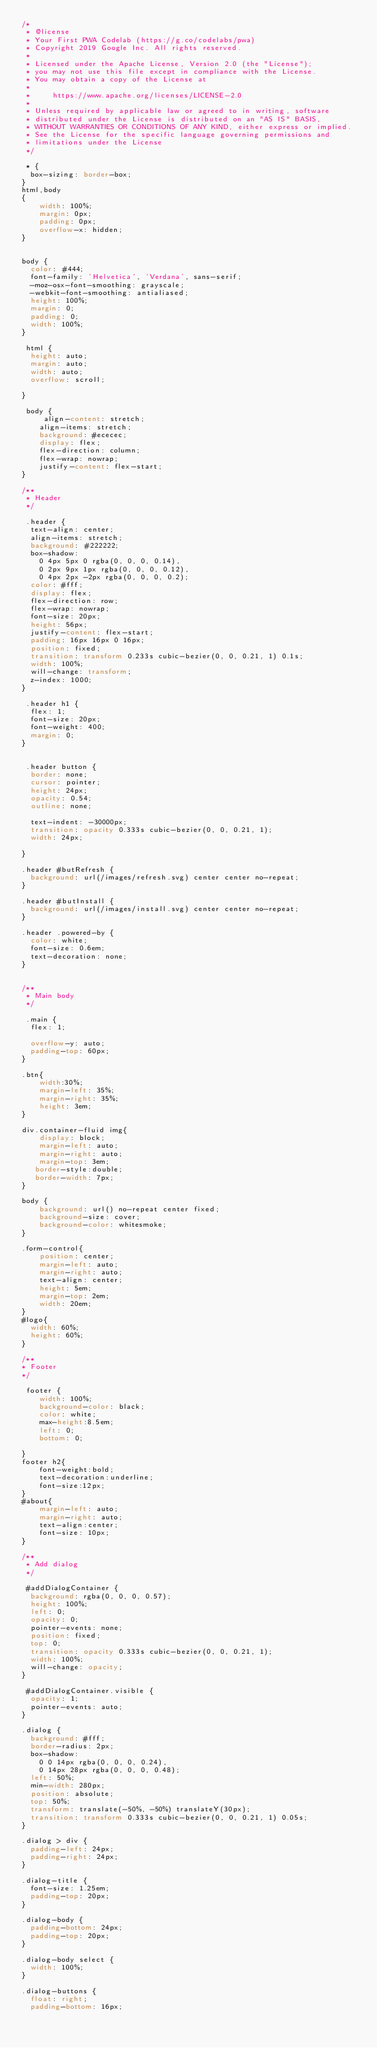<code> <loc_0><loc_0><loc_500><loc_500><_CSS_>/*
 * @license
 * Your First PWA Codelab (https://g.co/codelabs/pwa)
 * Copyright 2019 Google Inc. All rights reserved.
 *
 * Licensed under the Apache License, Version 2.0 (the "License");
 * you may not use this file except in compliance with the License.
 * You may obtain a copy of the License at
 *
 *     https://www.apache.org/licenses/LICENSE-2.0
 *
 * Unless required by applicable law or agreed to in writing, software
 * distributed under the License is distributed on an "AS IS" BASIS,
 * WITHOUT WARRANTIES OR CONDITIONS OF ANY KIND, either express or implied.
 * See the License for the specific language governing permissions and
 * limitations under the License
 */

 * {
  box-sizing: border-box;
}
html,body
{
    width: 100%;
    margin: 0px;
    padding: 0px;
    overflow-x: hidden;
}


body {
  color: #444;
  font-family: 'Helvetica', 'Verdana', sans-serif;
  -moz-osx-font-smoothing: grayscale;
  -webkit-font-smoothing: antialiased;
  height: 100%;
  margin: 0;
  padding: 0;
  width: 100%;
}

 html {
  height: auto;
  margin: auto;
  width: auto;
  overflow: scroll;

}

 body {
     align-content: stretch;
    align-items: stretch;
    background: #ececec;
    display: flex;
    flex-direction: column;
    flex-wrap: nowrap;
    justify-content: flex-start;
}

/**
 * Header
 */

 .header {
  text-align: center;
  align-items: stretch;
  background: #222222;
  box-shadow:
    0 4px 5px 0 rgba(0, 0, 0, 0.14),
    0 2px 9px 1px rgba(0, 0, 0, 0.12),
    0 4px 2px -2px rgba(0, 0, 0, 0.2);
  color: #fff;
  display: flex;
  flex-direction: row;
  flex-wrap: nowrap;
  font-size: 20px;
  height: 56px;
  justify-content: flex-start;
  padding: 16px 16px 0 16px;
  position: fixed;
  transition: transform 0.233s cubic-bezier(0, 0, 0.21, 1) 0.1s;
  width: 100%;
  will-change: transform;
  z-index: 1000;
}

 .header h1 {
  flex: 1;
  font-size: 20px;
  font-weight: 400;
  margin: 0;
}


 .header button {
  border: none;
  cursor: pointer;
  height: 24px;
  opacity: 0.54;
  outline: none;

  text-indent: -30000px;
  transition: opacity 0.333s cubic-bezier(0, 0, 0.21, 1);
  width: 24px;

}

.header #butRefresh {
  background: url(/images/refresh.svg) center center no-repeat;
}

.header #butInstall {
  background: url(/images/install.svg) center center no-repeat;
}

.header .powered-by {
  color: white;
  font-size: 0.6em;
  text-decoration: none;
}


/**
 * Main body
 */

 .main {
  flex: 1;

  overflow-y: auto;
  padding-top: 60px;
}

.btn{
    width:30%;
    margin-left: 35%;
    margin-right: 35%;
    height: 3em;
}

div.container-fluid img{
    display: block;
    margin-left: auto;
    margin-right: auto;
    margin-top: 3em;
   border-style:double;
   border-width: 7px;
}

body {
    background: url() no-repeat center fixed;
    background-size: cover;
    background-color: whitesmoke;
}

.form-control{
    position: center;
    margin-left: auto;
    margin-right: auto;
    text-align: center;
    height: 5em;
    margin-top: 2em;
    width: 20em;
}
#logo{
  width: 60%;
  height: 60%;
}

/**
* Footer
*/

 footer {
    width: 100%;
    background-color: black;
    color: white;
    max-height:8.5em;
    left: 0;
    bottom: 0;

}
footer h2{
    font-weight:bold;
    text-decoration:underline;
    font-size:12px;
}
#about{
    margin-left: auto;
    margin-right: auto;
    text-align:center;
    font-size: 10px;
}

/**
 * Add dialog
 */

 #addDialogContainer {
  background: rgba(0, 0, 0, 0.57);
  height: 100%;
  left: 0;
  opacity: 0;
  pointer-events: none;
  position: fixed;
  top: 0;
  transition: opacity 0.333s cubic-bezier(0, 0, 0.21, 1);
  width: 100%;
  will-change: opacity;
}

 #addDialogContainer.visible {
  opacity: 1;
  pointer-events: auto;
}

.dialog {
  background: #fff;
  border-radius: 2px;
  box-shadow:
    0 0 14px rgba(0, 0, 0, 0.24),
    0 14px 28px rgba(0, 0, 0, 0.48);
  left: 50%;
  min-width: 280px;
  position: absolute;
  top: 50%;
  transform: translate(-50%, -50%) translateY(30px);
  transition: transform 0.333s cubic-bezier(0, 0, 0.21, 1) 0.05s;
}

.dialog > div {
  padding-left: 24px;
  padding-right: 24px;
}

.dialog-title {
  font-size: 1.25em;
  padding-top: 20px;
}

.dialog-body {
  padding-bottom: 24px;
  padding-top: 20px;
}

.dialog-body select {
  width: 100%;
}

.dialog-buttons {
  float: right;
  padding-bottom: 16px;</code> 